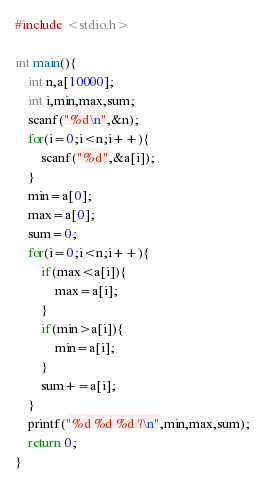Convert code to text. <code><loc_0><loc_0><loc_500><loc_500><_C_>#include <stdio.h>

int main(){
    int n,a[10000];
    int i,min,max,sum;
    scanf("%d\n",&n);
    for(i=0;i<n;i++){
        scanf("%d",&a[i]);
    }
    min=a[0];
    max=a[0];
    sum=0;
    for(i=0;i<n;i++){
        if(max<a[i]){
            max=a[i];
        }
        if(min>a[i]){
            min=a[i];
        }
        sum+=a[i];
    }
    printf("%d %d %d ?\n",min,max,sum);
    return 0;
}</code> 